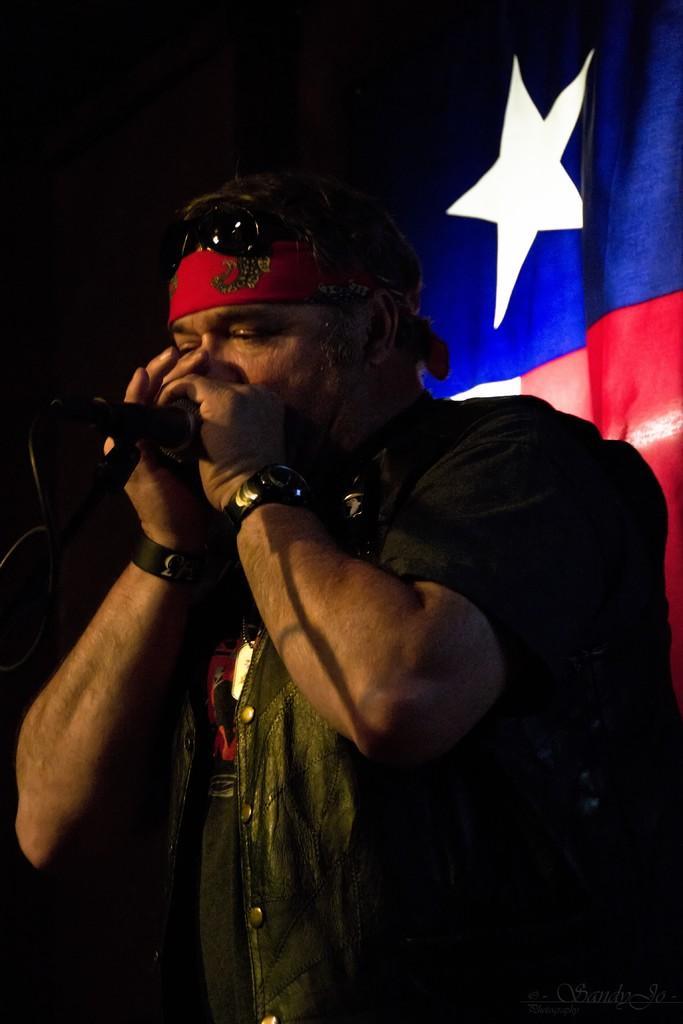Describe this image in one or two sentences. In this image I can see a person is holding a mike in hand. In the background I can see a curtain. This image is taken may be on the stage during night. 